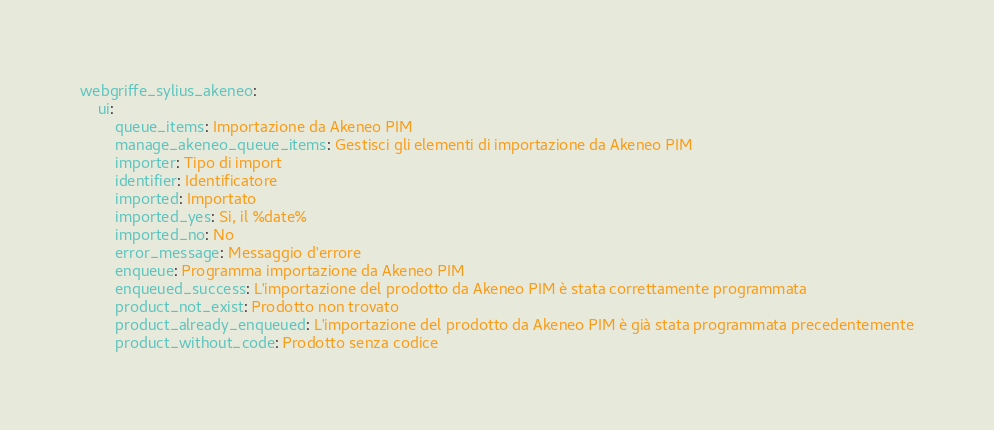Convert code to text. <code><loc_0><loc_0><loc_500><loc_500><_YAML_>webgriffe_sylius_akeneo:
    ui:
        queue_items: Importazione da Akeneo PIM
        manage_akeneo_queue_items: Gestisci gli elementi di importazione da Akeneo PIM
        importer: Tipo di import
        identifier: Identificatore
        imported: Importato
        imported_yes: Si, il %date%
        imported_no: No
        error_message: Messaggio d'errore
        enqueue: Programma importazione da Akeneo PIM
        enqueued_success: L'importazione del prodotto da Akeneo PIM è stata correttamente programmata
        product_not_exist: Prodotto non trovato
        product_already_enqueued: L'importazione del prodotto da Akeneo PIM è già stata programmata precedentemente
        product_without_code: Prodotto senza codice
</code> 